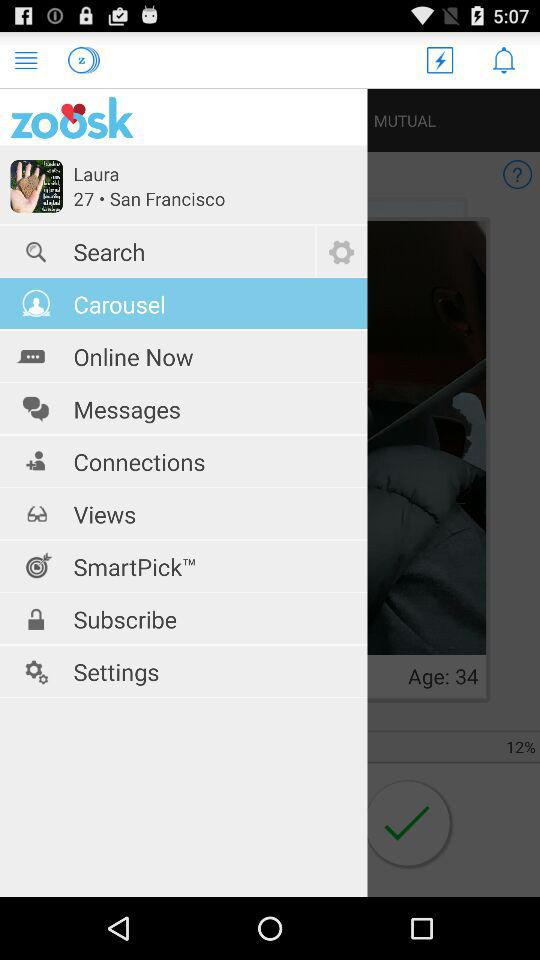How old is Laura? Laura is 27 years old. 